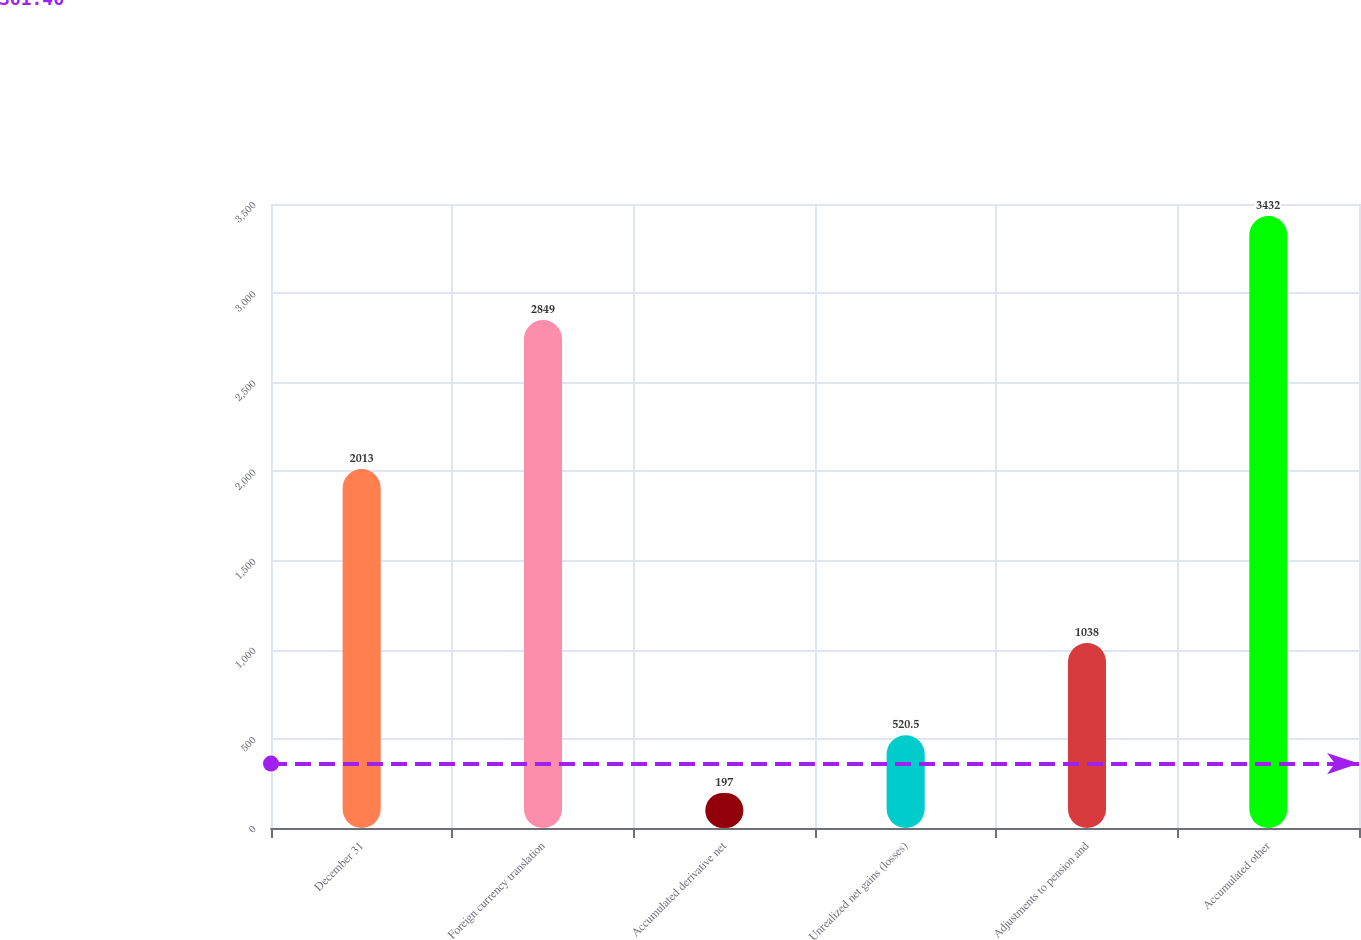Convert chart to OTSL. <chart><loc_0><loc_0><loc_500><loc_500><bar_chart><fcel>December 31<fcel>Foreign currency translation<fcel>Accumulated derivative net<fcel>Unrealized net gains (losses)<fcel>Adjustments to pension and<fcel>Accumulated other<nl><fcel>2013<fcel>2849<fcel>197<fcel>520.5<fcel>1038<fcel>3432<nl></chart> 